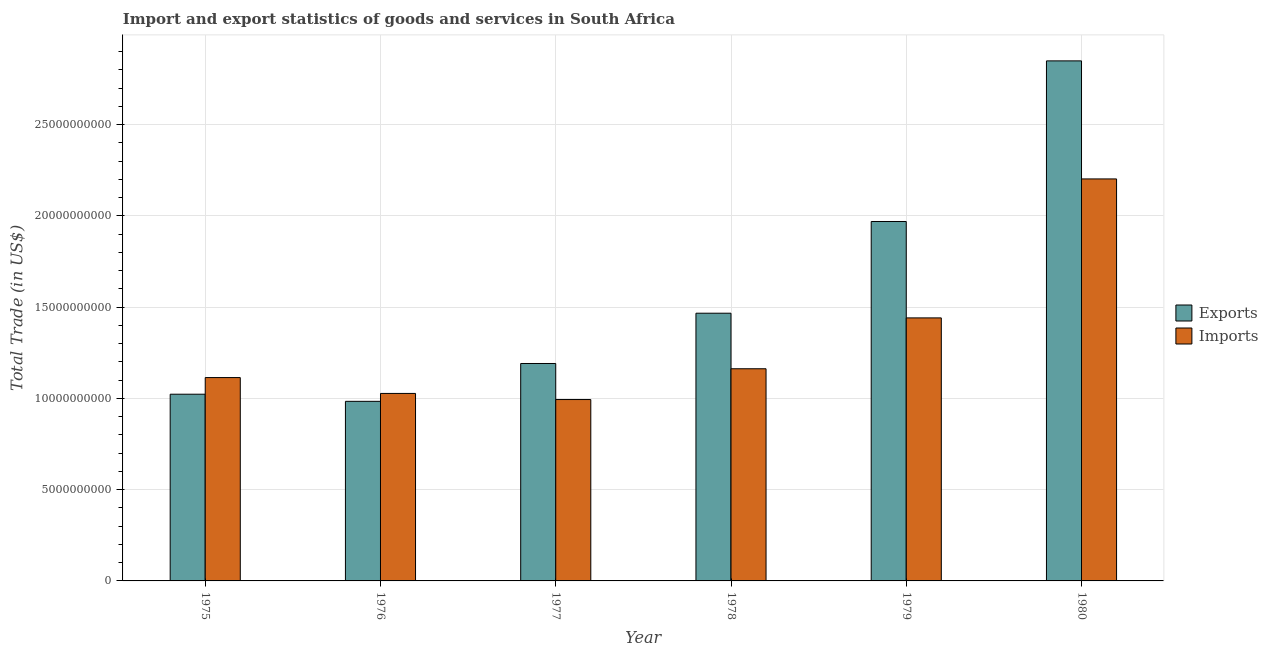How many groups of bars are there?
Your response must be concise. 6. Are the number of bars on each tick of the X-axis equal?
Give a very brief answer. Yes. How many bars are there on the 2nd tick from the left?
Offer a very short reply. 2. How many bars are there on the 3rd tick from the right?
Offer a terse response. 2. What is the label of the 6th group of bars from the left?
Your response must be concise. 1980. In how many cases, is the number of bars for a given year not equal to the number of legend labels?
Keep it short and to the point. 0. What is the export of goods and services in 1977?
Your response must be concise. 1.19e+1. Across all years, what is the maximum export of goods and services?
Provide a short and direct response. 2.85e+1. Across all years, what is the minimum export of goods and services?
Keep it short and to the point. 9.84e+09. In which year was the export of goods and services minimum?
Provide a succinct answer. 1976. What is the total imports of goods and services in the graph?
Provide a succinct answer. 7.94e+1. What is the difference between the export of goods and services in 1978 and that in 1979?
Offer a terse response. -5.03e+09. What is the difference between the imports of goods and services in 1975 and the export of goods and services in 1977?
Give a very brief answer. 1.20e+09. What is the average export of goods and services per year?
Provide a succinct answer. 1.58e+1. In how many years, is the imports of goods and services greater than 28000000000 US$?
Provide a succinct answer. 0. What is the ratio of the export of goods and services in 1976 to that in 1978?
Give a very brief answer. 0.67. Is the export of goods and services in 1977 less than that in 1978?
Give a very brief answer. Yes. What is the difference between the highest and the second highest export of goods and services?
Provide a succinct answer. 8.80e+09. What is the difference between the highest and the lowest export of goods and services?
Offer a very short reply. 1.87e+1. Is the sum of the export of goods and services in 1977 and 1980 greater than the maximum imports of goods and services across all years?
Offer a terse response. Yes. What does the 2nd bar from the left in 1980 represents?
Provide a short and direct response. Imports. What does the 1st bar from the right in 1975 represents?
Keep it short and to the point. Imports. How many bars are there?
Give a very brief answer. 12. Are all the bars in the graph horizontal?
Keep it short and to the point. No. How many years are there in the graph?
Your answer should be very brief. 6. What is the difference between two consecutive major ticks on the Y-axis?
Offer a terse response. 5.00e+09. Does the graph contain any zero values?
Give a very brief answer. No. Does the graph contain grids?
Offer a very short reply. Yes. How many legend labels are there?
Provide a succinct answer. 2. What is the title of the graph?
Your answer should be compact. Import and export statistics of goods and services in South Africa. What is the label or title of the Y-axis?
Provide a short and direct response. Total Trade (in US$). What is the Total Trade (in US$) in Exports in 1975?
Your answer should be compact. 1.02e+1. What is the Total Trade (in US$) in Imports in 1975?
Provide a short and direct response. 1.11e+1. What is the Total Trade (in US$) in Exports in 1976?
Offer a terse response. 9.84e+09. What is the Total Trade (in US$) in Imports in 1976?
Ensure brevity in your answer.  1.03e+1. What is the Total Trade (in US$) in Exports in 1977?
Provide a short and direct response. 1.19e+1. What is the Total Trade (in US$) in Imports in 1977?
Provide a short and direct response. 9.94e+09. What is the Total Trade (in US$) of Exports in 1978?
Your response must be concise. 1.47e+1. What is the Total Trade (in US$) in Imports in 1978?
Offer a terse response. 1.16e+1. What is the Total Trade (in US$) of Exports in 1979?
Your answer should be very brief. 1.97e+1. What is the Total Trade (in US$) of Imports in 1979?
Give a very brief answer. 1.44e+1. What is the Total Trade (in US$) of Exports in 1980?
Your answer should be compact. 2.85e+1. What is the Total Trade (in US$) of Imports in 1980?
Provide a short and direct response. 2.20e+1. Across all years, what is the maximum Total Trade (in US$) of Exports?
Offer a terse response. 2.85e+1. Across all years, what is the maximum Total Trade (in US$) in Imports?
Your answer should be compact. 2.20e+1. Across all years, what is the minimum Total Trade (in US$) in Exports?
Your answer should be very brief. 9.84e+09. Across all years, what is the minimum Total Trade (in US$) of Imports?
Make the answer very short. 9.94e+09. What is the total Total Trade (in US$) of Exports in the graph?
Your answer should be compact. 9.48e+1. What is the total Total Trade (in US$) of Imports in the graph?
Offer a terse response. 7.94e+1. What is the difference between the Total Trade (in US$) in Exports in 1975 and that in 1976?
Provide a short and direct response. 3.91e+08. What is the difference between the Total Trade (in US$) in Imports in 1975 and that in 1976?
Keep it short and to the point. 8.68e+08. What is the difference between the Total Trade (in US$) in Exports in 1975 and that in 1977?
Ensure brevity in your answer.  -1.68e+09. What is the difference between the Total Trade (in US$) in Imports in 1975 and that in 1977?
Your answer should be compact. 1.20e+09. What is the difference between the Total Trade (in US$) of Exports in 1975 and that in 1978?
Offer a terse response. -4.44e+09. What is the difference between the Total Trade (in US$) of Imports in 1975 and that in 1978?
Offer a very short reply. -4.83e+08. What is the difference between the Total Trade (in US$) in Exports in 1975 and that in 1979?
Make the answer very short. -9.46e+09. What is the difference between the Total Trade (in US$) of Imports in 1975 and that in 1979?
Your response must be concise. -3.27e+09. What is the difference between the Total Trade (in US$) of Exports in 1975 and that in 1980?
Ensure brevity in your answer.  -1.83e+1. What is the difference between the Total Trade (in US$) in Imports in 1975 and that in 1980?
Provide a succinct answer. -1.09e+1. What is the difference between the Total Trade (in US$) in Exports in 1976 and that in 1977?
Give a very brief answer. -2.07e+09. What is the difference between the Total Trade (in US$) of Imports in 1976 and that in 1977?
Your response must be concise. 3.35e+08. What is the difference between the Total Trade (in US$) of Exports in 1976 and that in 1978?
Make the answer very short. -4.83e+09. What is the difference between the Total Trade (in US$) of Imports in 1976 and that in 1978?
Make the answer very short. -1.35e+09. What is the difference between the Total Trade (in US$) of Exports in 1976 and that in 1979?
Give a very brief answer. -9.85e+09. What is the difference between the Total Trade (in US$) in Imports in 1976 and that in 1979?
Give a very brief answer. -4.14e+09. What is the difference between the Total Trade (in US$) of Exports in 1976 and that in 1980?
Your response must be concise. -1.87e+1. What is the difference between the Total Trade (in US$) in Imports in 1976 and that in 1980?
Offer a very short reply. -1.18e+1. What is the difference between the Total Trade (in US$) in Exports in 1977 and that in 1978?
Make the answer very short. -2.76e+09. What is the difference between the Total Trade (in US$) of Imports in 1977 and that in 1978?
Make the answer very short. -1.69e+09. What is the difference between the Total Trade (in US$) in Exports in 1977 and that in 1979?
Keep it short and to the point. -7.78e+09. What is the difference between the Total Trade (in US$) in Imports in 1977 and that in 1979?
Provide a succinct answer. -4.47e+09. What is the difference between the Total Trade (in US$) in Exports in 1977 and that in 1980?
Ensure brevity in your answer.  -1.66e+1. What is the difference between the Total Trade (in US$) in Imports in 1977 and that in 1980?
Provide a succinct answer. -1.21e+1. What is the difference between the Total Trade (in US$) in Exports in 1978 and that in 1979?
Provide a succinct answer. -5.03e+09. What is the difference between the Total Trade (in US$) in Imports in 1978 and that in 1979?
Offer a very short reply. -2.79e+09. What is the difference between the Total Trade (in US$) of Exports in 1978 and that in 1980?
Your answer should be very brief. -1.38e+1. What is the difference between the Total Trade (in US$) in Imports in 1978 and that in 1980?
Ensure brevity in your answer.  -1.04e+1. What is the difference between the Total Trade (in US$) of Exports in 1979 and that in 1980?
Keep it short and to the point. -8.80e+09. What is the difference between the Total Trade (in US$) of Imports in 1979 and that in 1980?
Your response must be concise. -7.61e+09. What is the difference between the Total Trade (in US$) in Exports in 1975 and the Total Trade (in US$) in Imports in 1976?
Make the answer very short. -4.30e+07. What is the difference between the Total Trade (in US$) of Exports in 1975 and the Total Trade (in US$) of Imports in 1977?
Your answer should be compact. 2.92e+08. What is the difference between the Total Trade (in US$) in Exports in 1975 and the Total Trade (in US$) in Imports in 1978?
Keep it short and to the point. -1.39e+09. What is the difference between the Total Trade (in US$) of Exports in 1975 and the Total Trade (in US$) of Imports in 1979?
Provide a succinct answer. -4.18e+09. What is the difference between the Total Trade (in US$) of Exports in 1975 and the Total Trade (in US$) of Imports in 1980?
Offer a terse response. -1.18e+1. What is the difference between the Total Trade (in US$) of Exports in 1976 and the Total Trade (in US$) of Imports in 1977?
Keep it short and to the point. -9.89e+07. What is the difference between the Total Trade (in US$) in Exports in 1976 and the Total Trade (in US$) in Imports in 1978?
Ensure brevity in your answer.  -1.78e+09. What is the difference between the Total Trade (in US$) of Exports in 1976 and the Total Trade (in US$) of Imports in 1979?
Your answer should be very brief. -4.57e+09. What is the difference between the Total Trade (in US$) in Exports in 1976 and the Total Trade (in US$) in Imports in 1980?
Make the answer very short. -1.22e+1. What is the difference between the Total Trade (in US$) in Exports in 1977 and the Total Trade (in US$) in Imports in 1978?
Your answer should be compact. 2.89e+08. What is the difference between the Total Trade (in US$) of Exports in 1977 and the Total Trade (in US$) of Imports in 1979?
Make the answer very short. -2.50e+09. What is the difference between the Total Trade (in US$) in Exports in 1977 and the Total Trade (in US$) in Imports in 1980?
Offer a terse response. -1.01e+1. What is the difference between the Total Trade (in US$) of Exports in 1978 and the Total Trade (in US$) of Imports in 1979?
Provide a short and direct response. 2.56e+08. What is the difference between the Total Trade (in US$) in Exports in 1978 and the Total Trade (in US$) in Imports in 1980?
Provide a short and direct response. -7.36e+09. What is the difference between the Total Trade (in US$) in Exports in 1979 and the Total Trade (in US$) in Imports in 1980?
Offer a very short reply. -2.33e+09. What is the average Total Trade (in US$) in Exports per year?
Ensure brevity in your answer.  1.58e+1. What is the average Total Trade (in US$) of Imports per year?
Provide a short and direct response. 1.32e+1. In the year 1975, what is the difference between the Total Trade (in US$) in Exports and Total Trade (in US$) in Imports?
Offer a very short reply. -9.11e+08. In the year 1976, what is the difference between the Total Trade (in US$) of Exports and Total Trade (in US$) of Imports?
Your answer should be very brief. -4.34e+08. In the year 1977, what is the difference between the Total Trade (in US$) in Exports and Total Trade (in US$) in Imports?
Give a very brief answer. 1.97e+09. In the year 1978, what is the difference between the Total Trade (in US$) in Exports and Total Trade (in US$) in Imports?
Make the answer very short. 3.04e+09. In the year 1979, what is the difference between the Total Trade (in US$) in Exports and Total Trade (in US$) in Imports?
Offer a terse response. 5.28e+09. In the year 1980, what is the difference between the Total Trade (in US$) in Exports and Total Trade (in US$) in Imports?
Offer a terse response. 6.47e+09. What is the ratio of the Total Trade (in US$) of Exports in 1975 to that in 1976?
Offer a terse response. 1.04. What is the ratio of the Total Trade (in US$) in Imports in 1975 to that in 1976?
Ensure brevity in your answer.  1.08. What is the ratio of the Total Trade (in US$) of Exports in 1975 to that in 1977?
Give a very brief answer. 0.86. What is the ratio of the Total Trade (in US$) of Imports in 1975 to that in 1977?
Offer a very short reply. 1.12. What is the ratio of the Total Trade (in US$) of Exports in 1975 to that in 1978?
Provide a succinct answer. 0.7. What is the ratio of the Total Trade (in US$) in Imports in 1975 to that in 1978?
Offer a terse response. 0.96. What is the ratio of the Total Trade (in US$) in Exports in 1975 to that in 1979?
Provide a short and direct response. 0.52. What is the ratio of the Total Trade (in US$) of Imports in 1975 to that in 1979?
Provide a succinct answer. 0.77. What is the ratio of the Total Trade (in US$) of Exports in 1975 to that in 1980?
Offer a very short reply. 0.36. What is the ratio of the Total Trade (in US$) of Imports in 1975 to that in 1980?
Your answer should be compact. 0.51. What is the ratio of the Total Trade (in US$) of Exports in 1976 to that in 1977?
Give a very brief answer. 0.83. What is the ratio of the Total Trade (in US$) in Imports in 1976 to that in 1977?
Your answer should be compact. 1.03. What is the ratio of the Total Trade (in US$) of Exports in 1976 to that in 1978?
Give a very brief answer. 0.67. What is the ratio of the Total Trade (in US$) of Imports in 1976 to that in 1978?
Your answer should be compact. 0.88. What is the ratio of the Total Trade (in US$) of Exports in 1976 to that in 1979?
Provide a succinct answer. 0.5. What is the ratio of the Total Trade (in US$) in Imports in 1976 to that in 1979?
Your response must be concise. 0.71. What is the ratio of the Total Trade (in US$) of Exports in 1976 to that in 1980?
Your response must be concise. 0.35. What is the ratio of the Total Trade (in US$) of Imports in 1976 to that in 1980?
Your answer should be compact. 0.47. What is the ratio of the Total Trade (in US$) of Exports in 1977 to that in 1978?
Offer a terse response. 0.81. What is the ratio of the Total Trade (in US$) of Imports in 1977 to that in 1978?
Give a very brief answer. 0.85. What is the ratio of the Total Trade (in US$) in Exports in 1977 to that in 1979?
Your answer should be compact. 0.6. What is the ratio of the Total Trade (in US$) of Imports in 1977 to that in 1979?
Ensure brevity in your answer.  0.69. What is the ratio of the Total Trade (in US$) in Exports in 1977 to that in 1980?
Give a very brief answer. 0.42. What is the ratio of the Total Trade (in US$) in Imports in 1977 to that in 1980?
Your answer should be very brief. 0.45. What is the ratio of the Total Trade (in US$) of Exports in 1978 to that in 1979?
Offer a very short reply. 0.74. What is the ratio of the Total Trade (in US$) in Imports in 1978 to that in 1979?
Keep it short and to the point. 0.81. What is the ratio of the Total Trade (in US$) in Exports in 1978 to that in 1980?
Your answer should be very brief. 0.51. What is the ratio of the Total Trade (in US$) in Imports in 1978 to that in 1980?
Your answer should be compact. 0.53. What is the ratio of the Total Trade (in US$) of Exports in 1979 to that in 1980?
Keep it short and to the point. 0.69. What is the ratio of the Total Trade (in US$) in Imports in 1979 to that in 1980?
Your response must be concise. 0.65. What is the difference between the highest and the second highest Total Trade (in US$) in Exports?
Your answer should be very brief. 8.80e+09. What is the difference between the highest and the second highest Total Trade (in US$) of Imports?
Keep it short and to the point. 7.61e+09. What is the difference between the highest and the lowest Total Trade (in US$) of Exports?
Your response must be concise. 1.87e+1. What is the difference between the highest and the lowest Total Trade (in US$) in Imports?
Offer a terse response. 1.21e+1. 